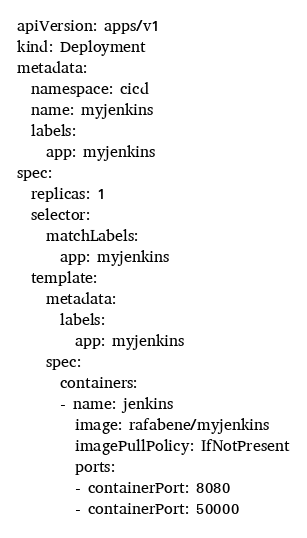<code> <loc_0><loc_0><loc_500><loc_500><_YAML_>apiVersion: apps/v1
kind: Deployment
metadata:
  namespace: cicd
  name: myjenkins
  labels:
    app: myjenkins
spec:
  replicas: 1
  selector:
    matchLabels:
      app: myjenkins
  template:
    metadata:
      labels:
        app: myjenkins
    spec:
      containers:
      - name: jenkins
        image: rafabene/myjenkins
        imagePullPolicy: IfNotPresent
        ports:
        - containerPort: 8080
        - containerPort: 50000
</code> 